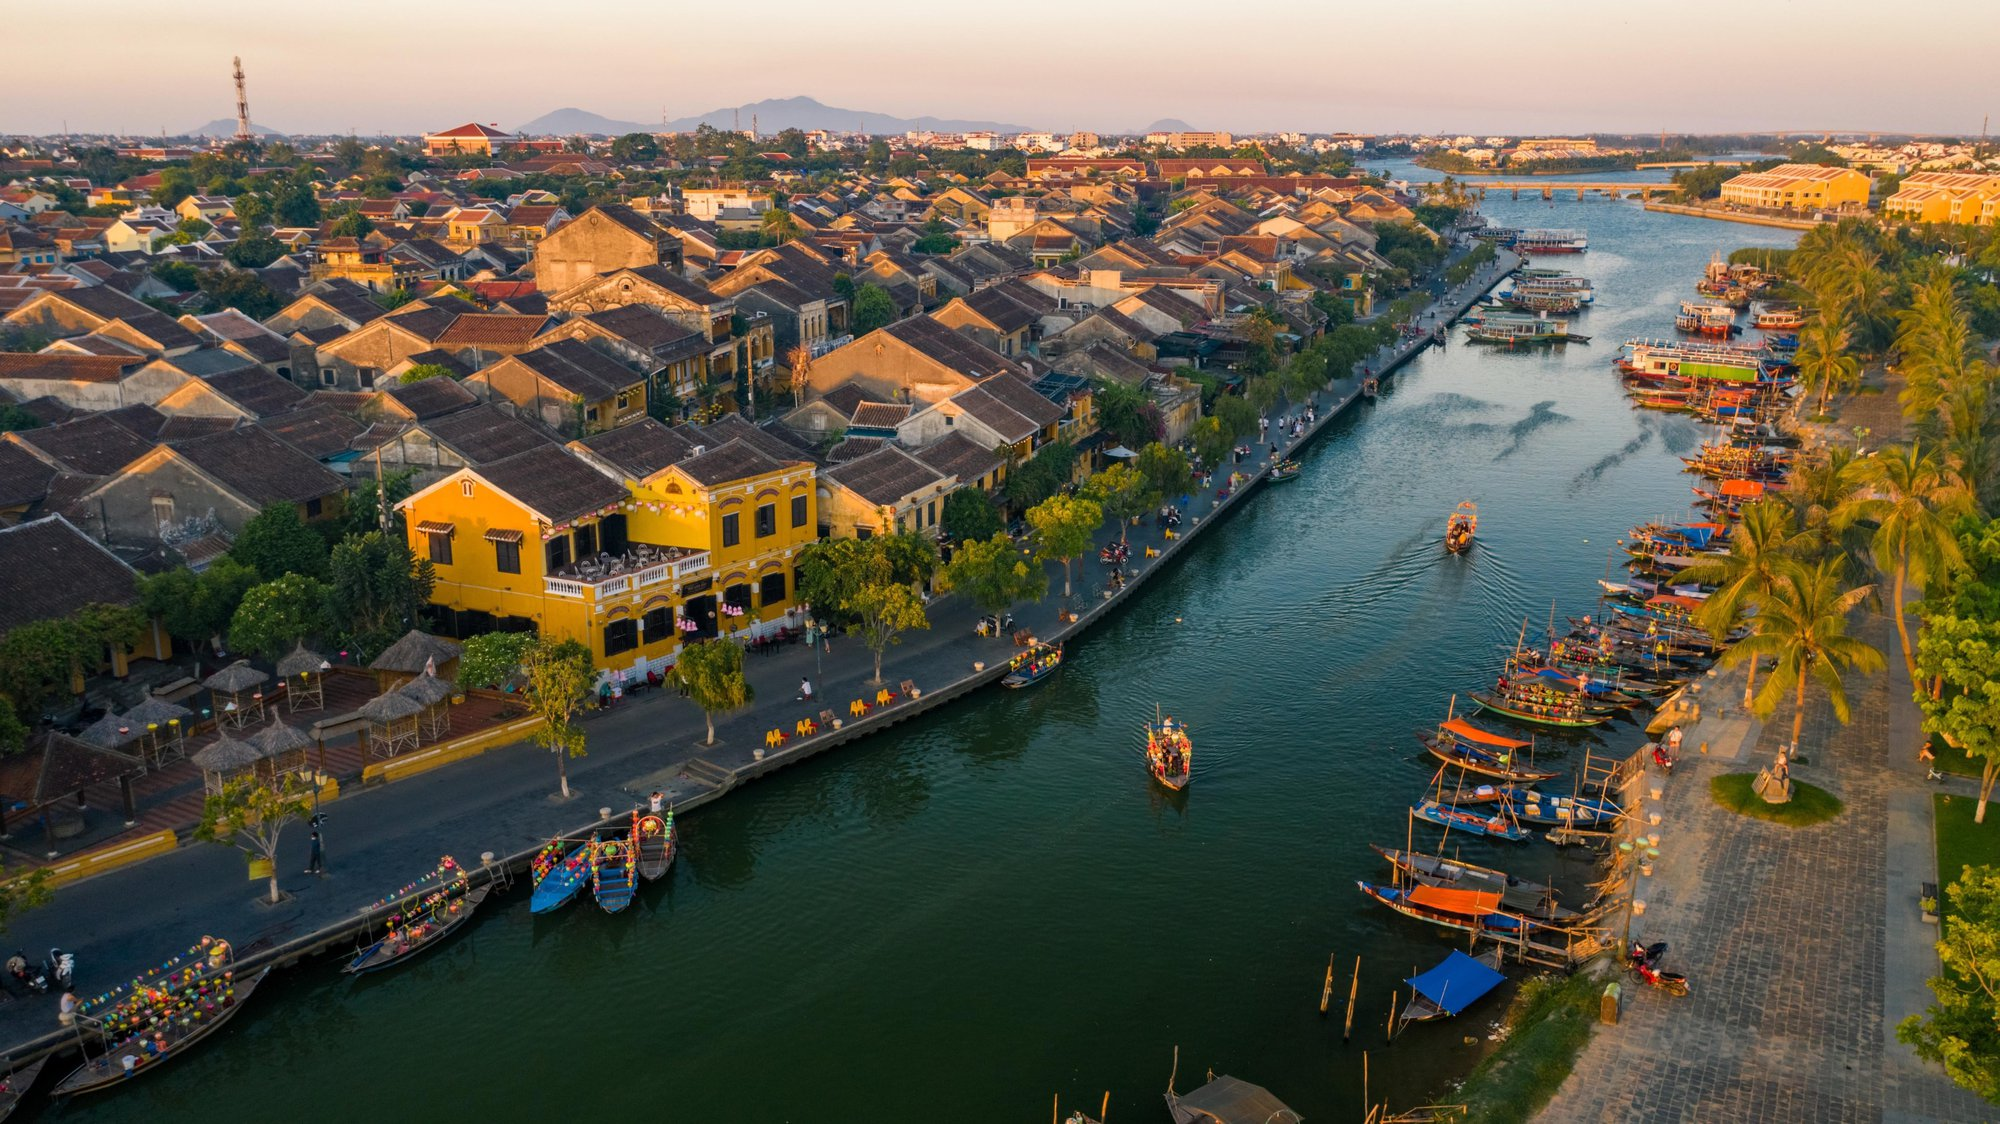How might a typical day unfold for a boatman in this riverside community? A typical day for a boatman in this riverside community might begin at sunrise. With the first light of dawn, he would prepare his boat, ensuring that the lanterns are in place and the hull is in good condition. He might start the day ferrying locals across the river, a routine trip for those who work or attend school on the opposite bank. As the morning progresses, he could take tourists on scenic cruises, sharing stories and highlighting historical and cultural points of interest along the way. In the afternoon, he might transport goods, helping traders move their products, thereby playing a crucial role in local commerce. As evening descends, the boatman could participate in a local festival or event, his boat becoming a part of the vibrant display of lights and colors on the river. Finally, as night falls, he would dock his boat, take a moment to reflect on the day by the quiet waters before heading home, ready to begin again with the next sunrise. 